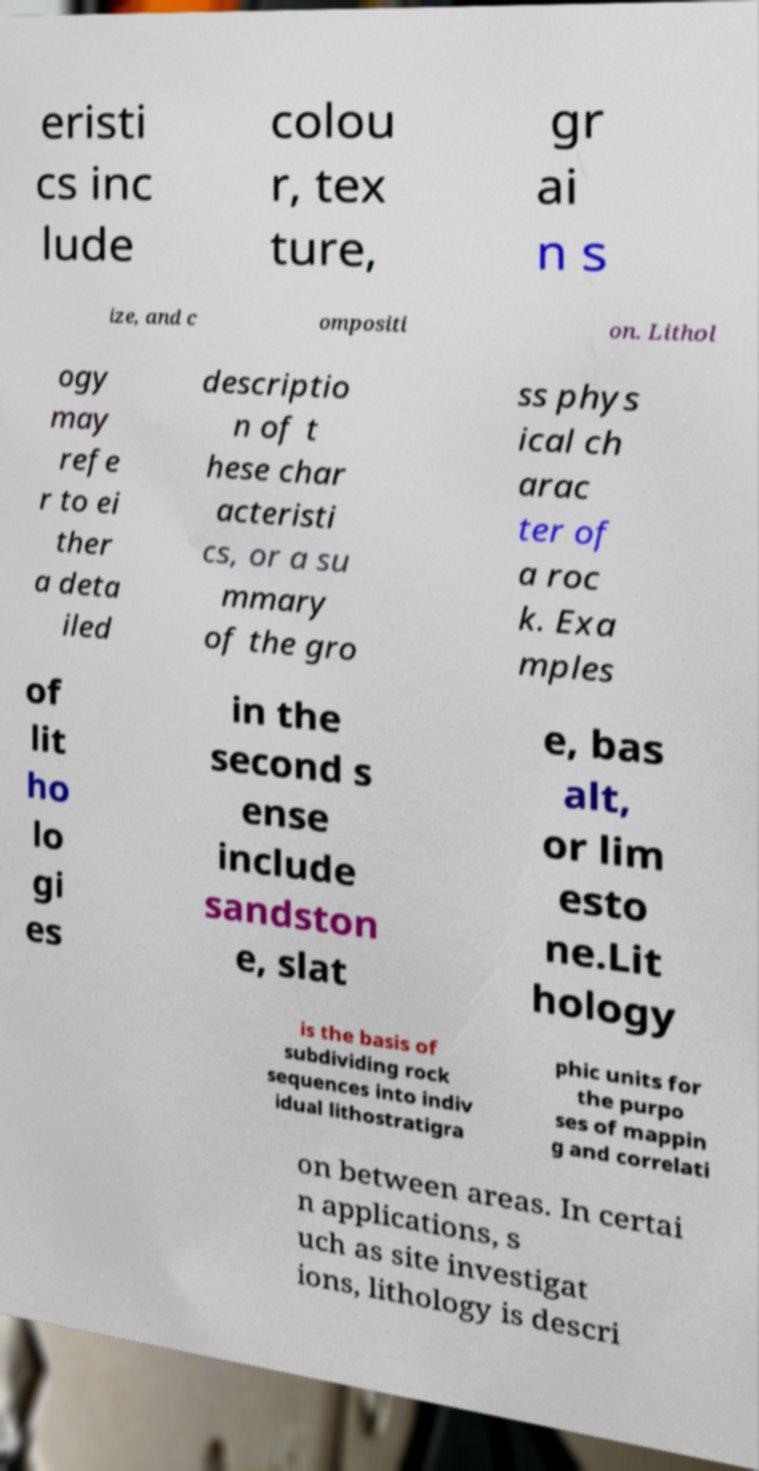Can you accurately transcribe the text from the provided image for me? eristi cs inc lude colou r, tex ture, gr ai n s ize, and c ompositi on. Lithol ogy may refe r to ei ther a deta iled descriptio n of t hese char acteristi cs, or a su mmary of the gro ss phys ical ch arac ter of a roc k. Exa mples of lit ho lo gi es in the second s ense include sandston e, slat e, bas alt, or lim esto ne.Lit hology is the basis of subdividing rock sequences into indiv idual lithostratigra phic units for the purpo ses of mappin g and correlati on between areas. In certai n applications, s uch as site investigat ions, lithology is descri 